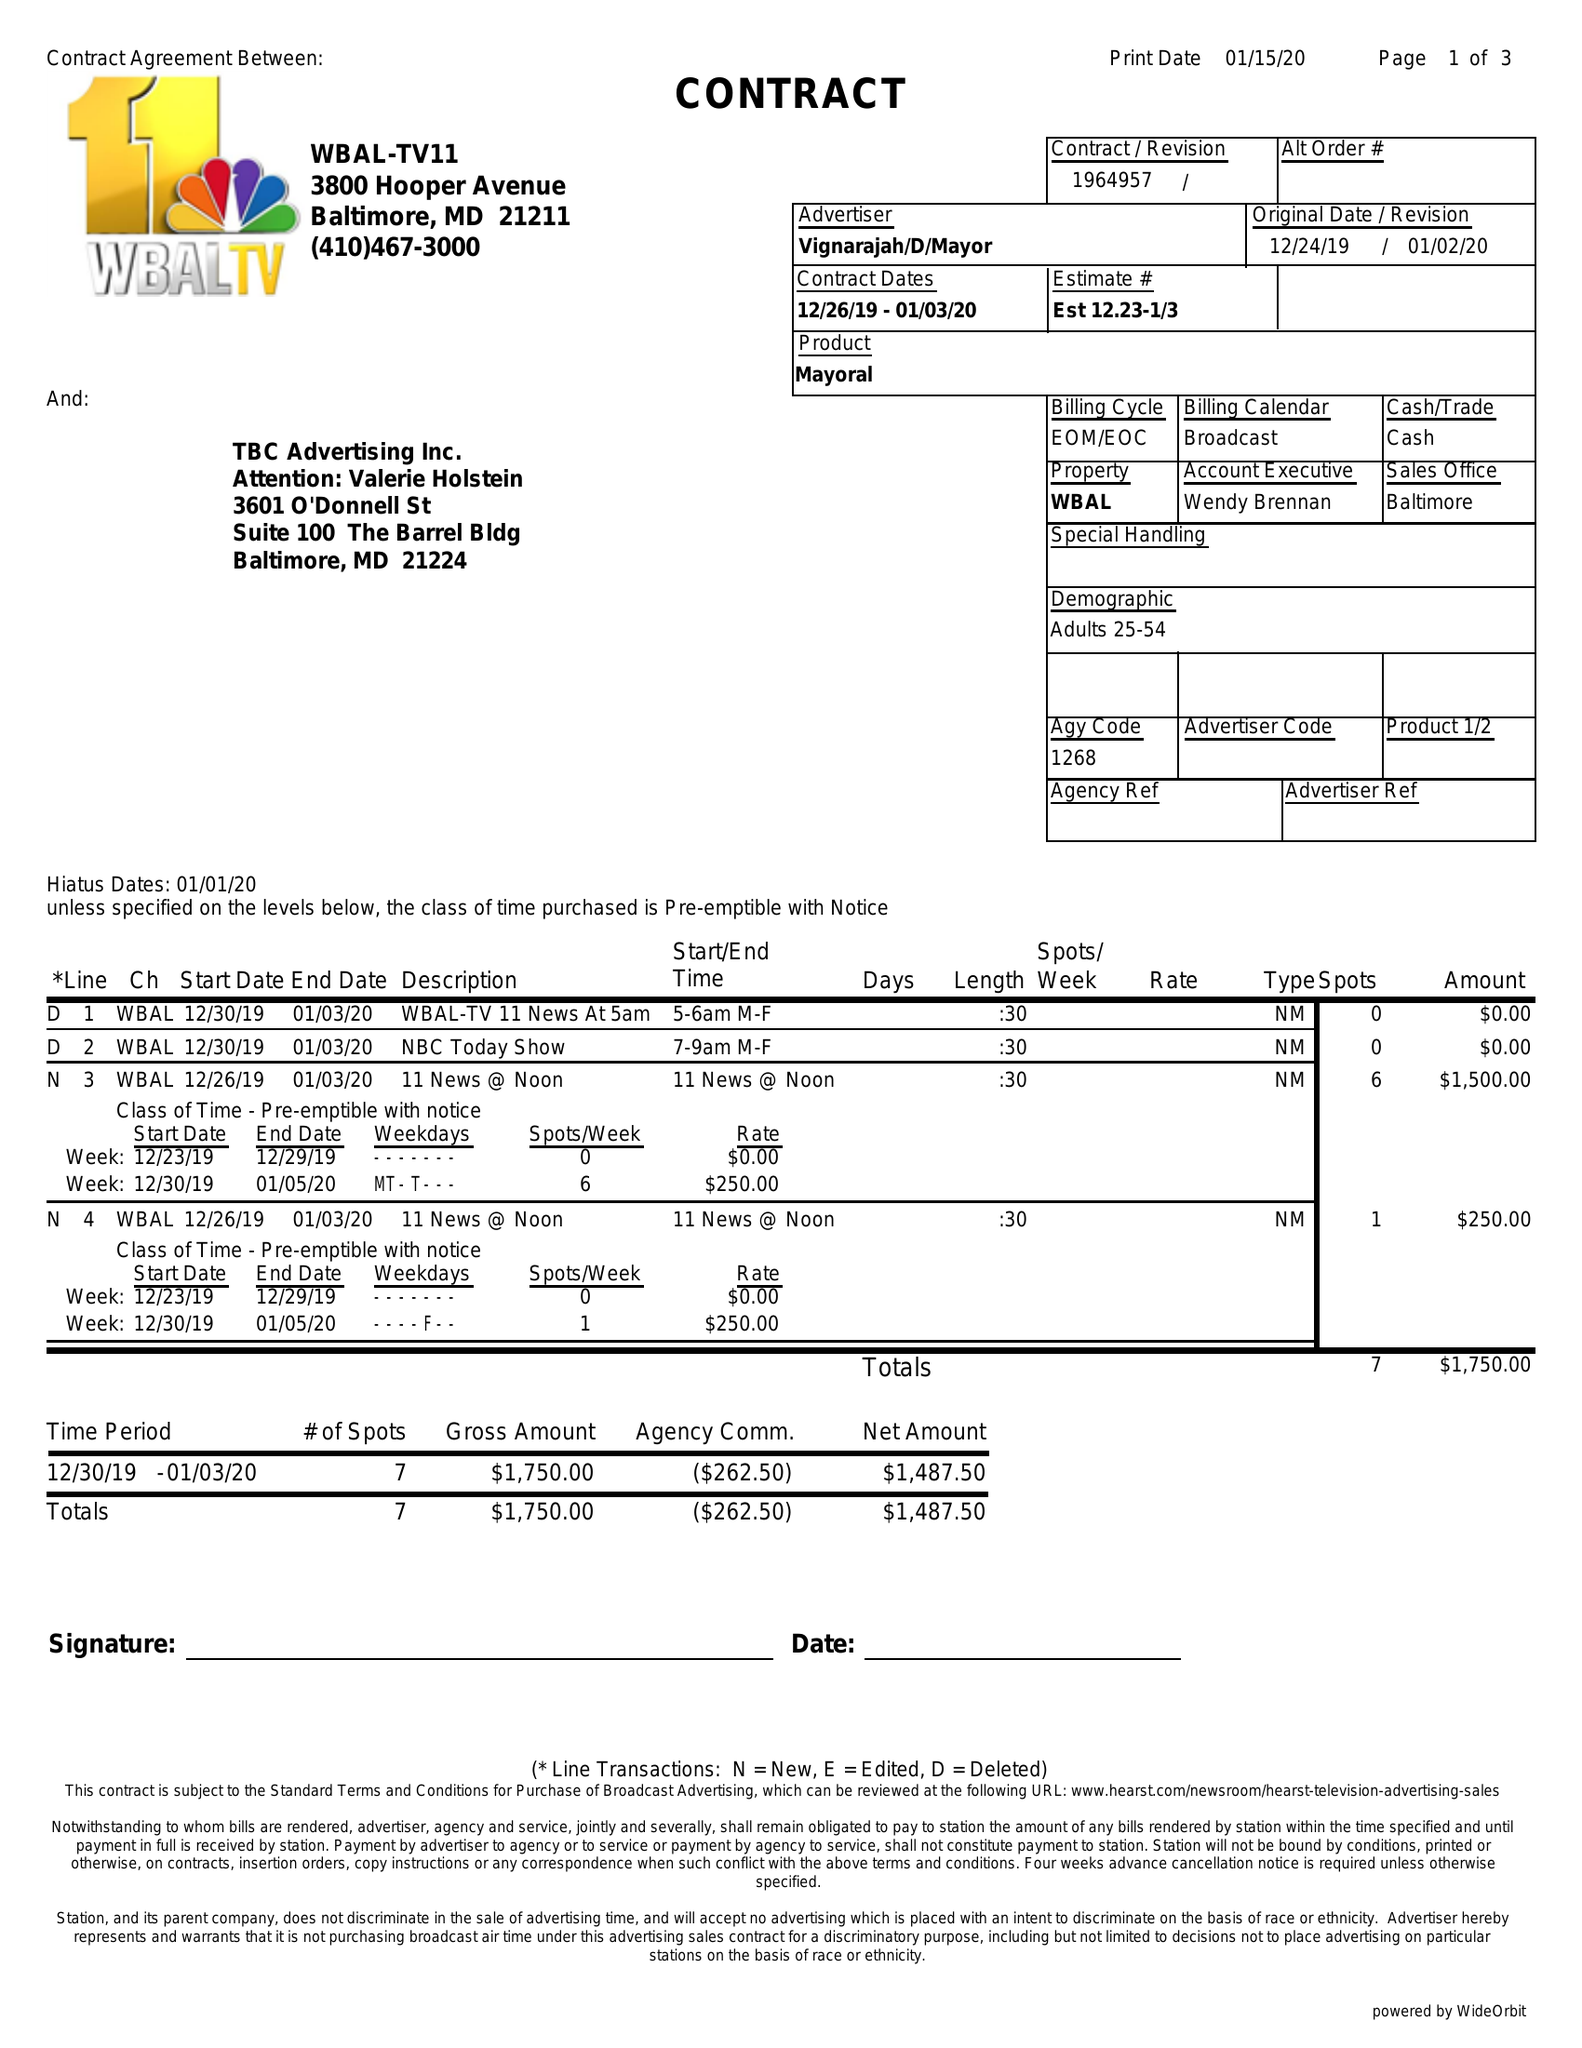What is the value for the contract_num?
Answer the question using a single word or phrase. 1964957 